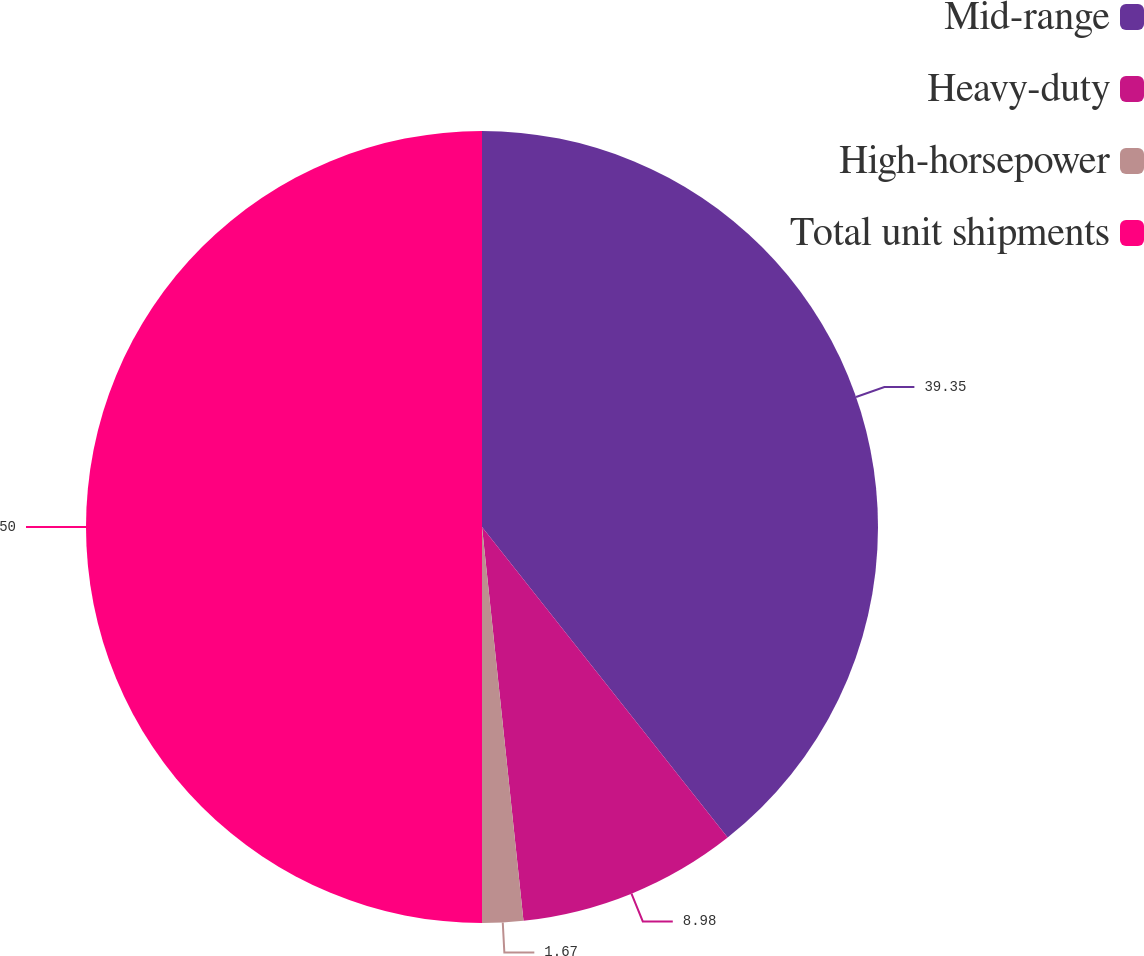<chart> <loc_0><loc_0><loc_500><loc_500><pie_chart><fcel>Mid-range<fcel>Heavy-duty<fcel>High-horsepower<fcel>Total unit shipments<nl><fcel>39.35%<fcel>8.98%<fcel>1.67%<fcel>50.0%<nl></chart> 